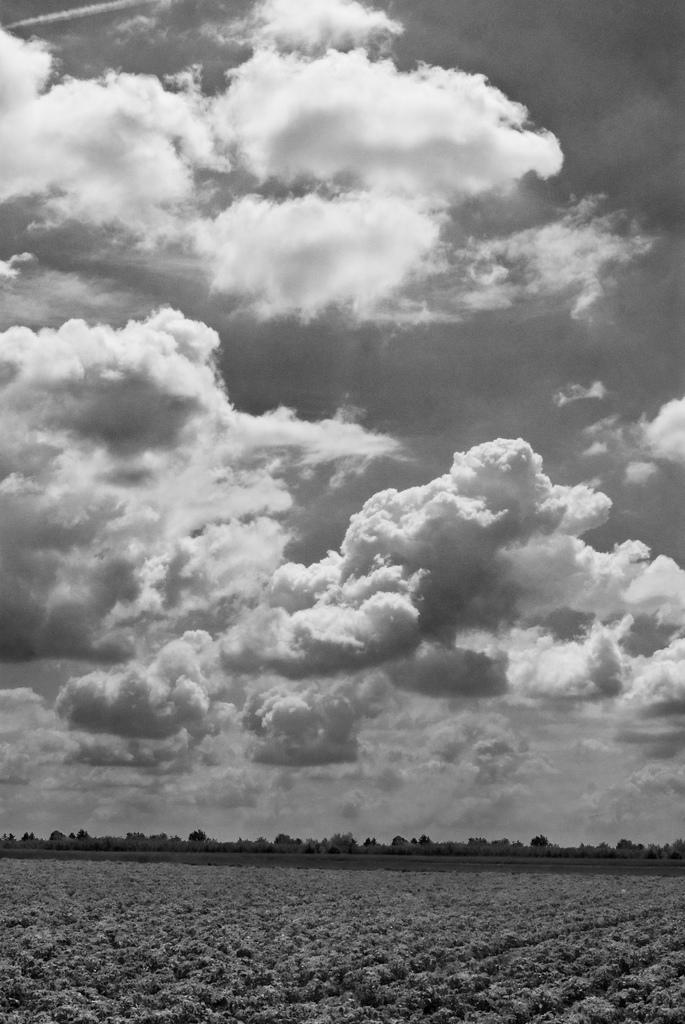What type of living organisms can be seen in the image? Plants can be seen in the image. What can be seen in the background of the image? There are trees in the background of the image. What is the condition of the sky in the image? The sky is cloudy in the image. How many balloons are floating in the sky in the image? There are no balloons visible in the image; it only features plants, trees, and a cloudy sky. What type of ice can be seen melting on the ground in the image? There is no ice present in the image. 